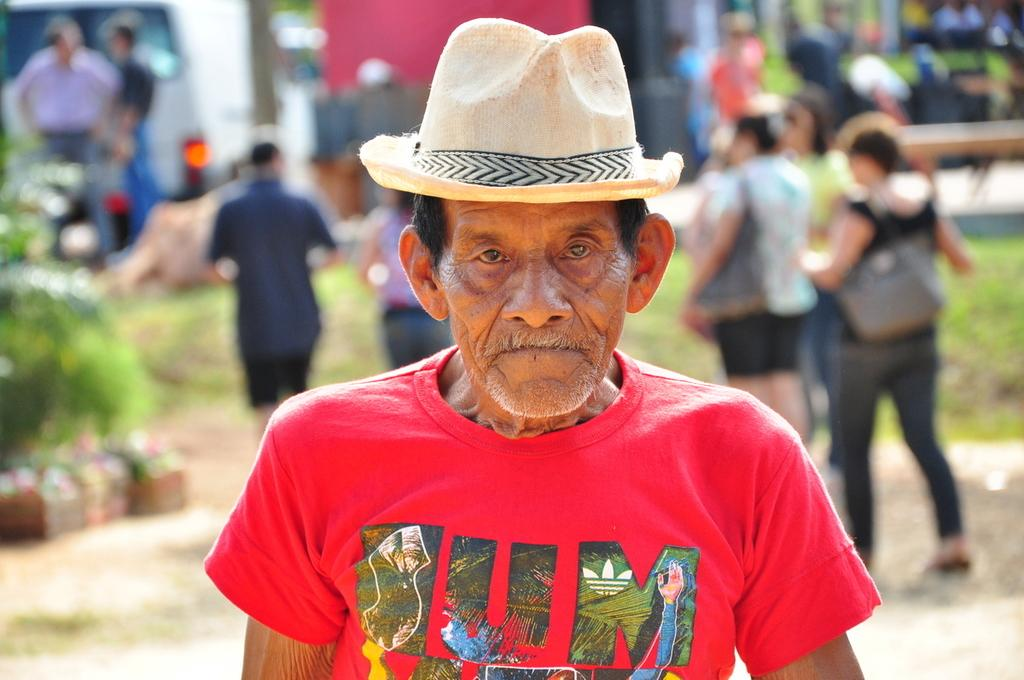Who is the main subject in the image? There is an old man in the image. Where is the old man located in relation to the image? The old man is in the foreground. What is the old man wearing on his head? The old man is wearing a hat. What color is the old man's T-shirt? The old man is wearing a red T-shirt. What type of deer can be seen in the image? There is no deer present in the image; it features an old man wearing a hat and a red T-shirt. What design is on the old man's hat? The provided facts do not mention any specific design on the old man's hat. 